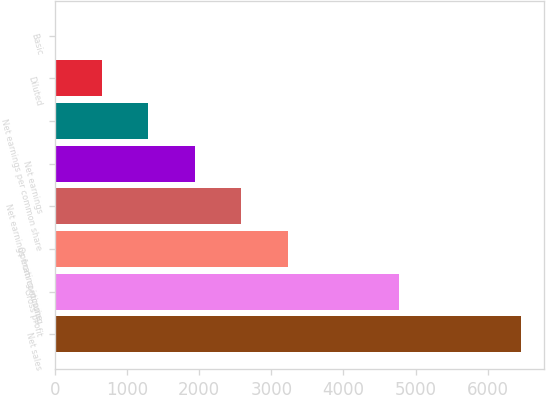Convert chart. <chart><loc_0><loc_0><loc_500><loc_500><bar_chart><fcel>Net sales<fcel>Gross profit<fcel>Operating income<fcel>Net earnings from continuing<fcel>Net earnings<fcel>Net earnings per common share<fcel>Diluted<fcel>Basic<nl><fcel>6463.8<fcel>4777.2<fcel>3232.49<fcel>2586.22<fcel>1939.95<fcel>1293.68<fcel>647.41<fcel>1.14<nl></chart> 